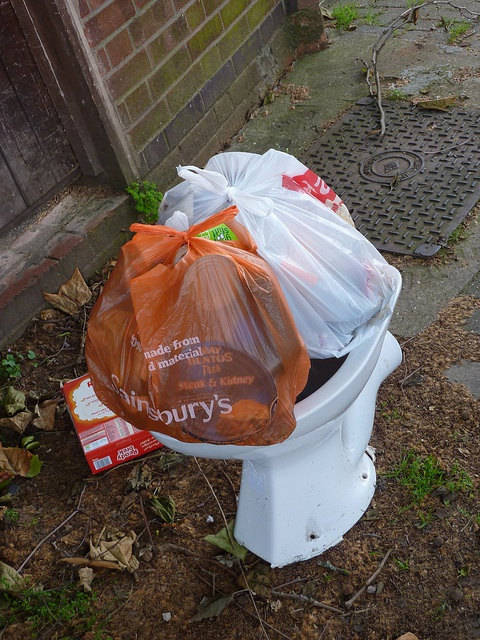Describe the objects in this image and their specific colors. I can see a toilet in black, lightblue, darkgray, and lavender tones in this image. 